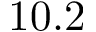Convert formula to latex. <formula><loc_0><loc_0><loc_500><loc_500>1 0 . 2</formula> 